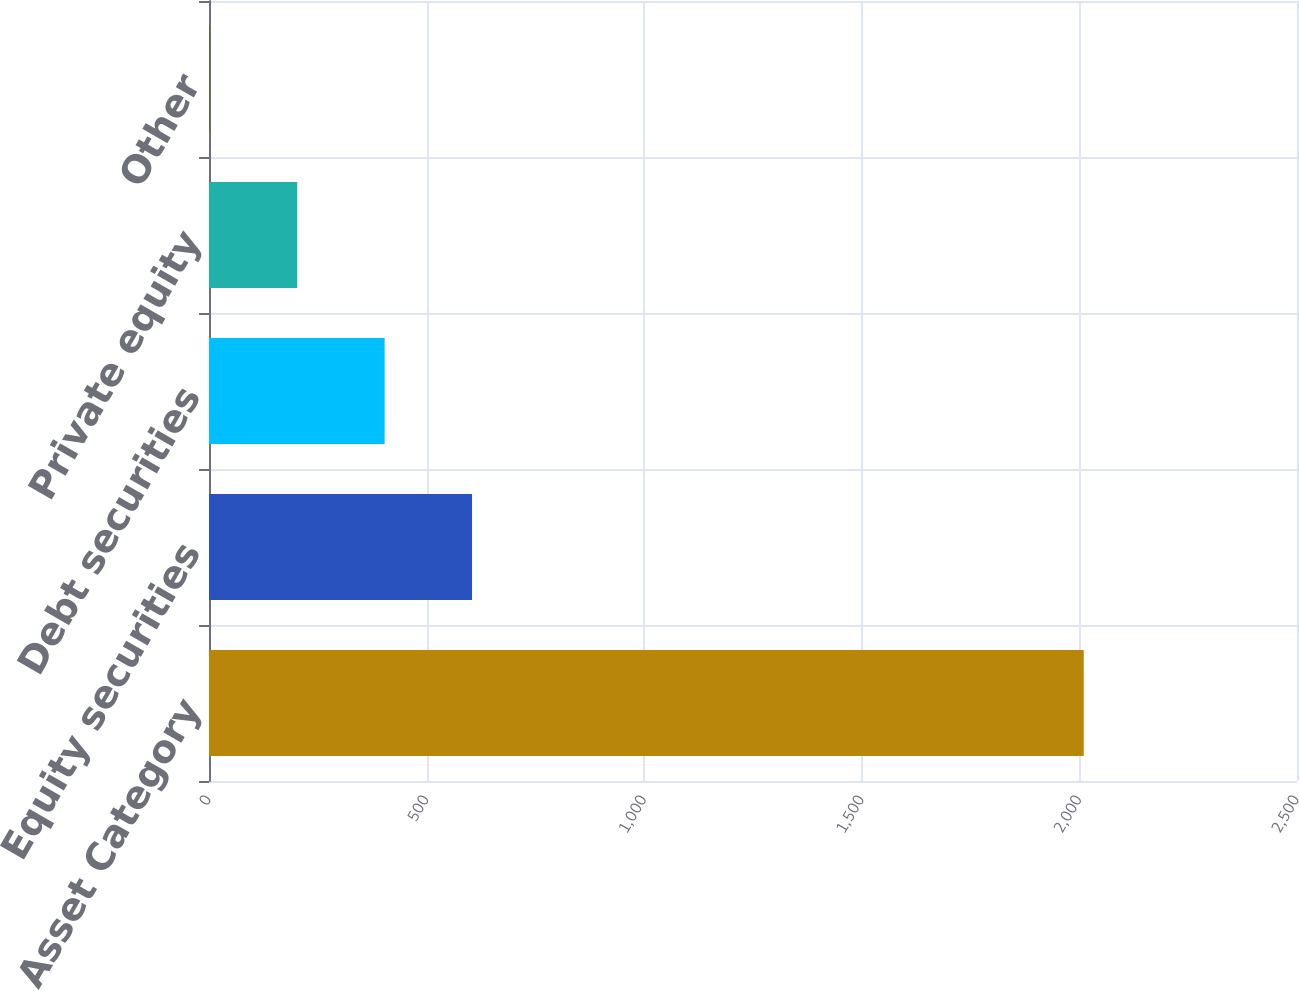Convert chart to OTSL. <chart><loc_0><loc_0><loc_500><loc_500><bar_chart><fcel>Asset Category<fcel>Equity securities<fcel>Debt securities<fcel>Private equity<fcel>Other<nl><fcel>2010<fcel>604.4<fcel>403.6<fcel>202.8<fcel>2<nl></chart> 